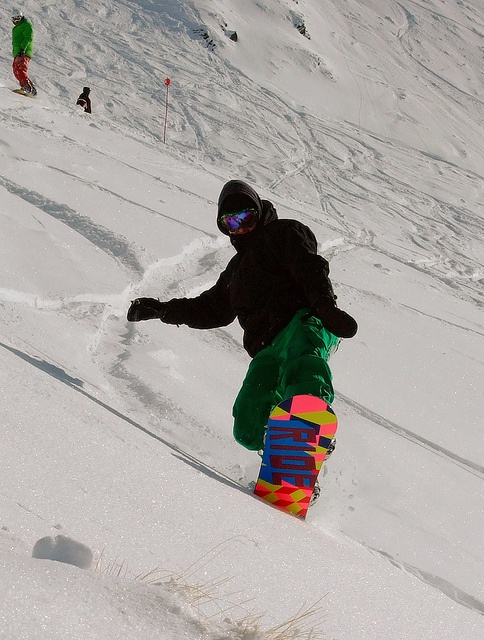Describe the objects in this image and their specific colors. I can see people in gray, black, darkgreen, and darkgray tones, snowboard in gray, maroon, navy, salmon, and olive tones, people in gray, darkgreen, maroon, black, and darkgray tones, and people in gray, black, darkgray, and lightgray tones in this image. 